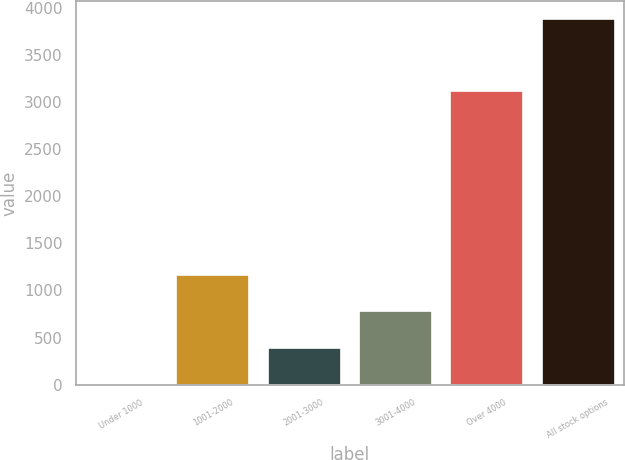Convert chart. <chart><loc_0><loc_0><loc_500><loc_500><bar_chart><fcel>Under 1000<fcel>1001-2000<fcel>2001-3000<fcel>3001-4000<fcel>Over 4000<fcel>All stock options<nl><fcel>5<fcel>1166.6<fcel>392.2<fcel>779.4<fcel>3113<fcel>3877<nl></chart> 